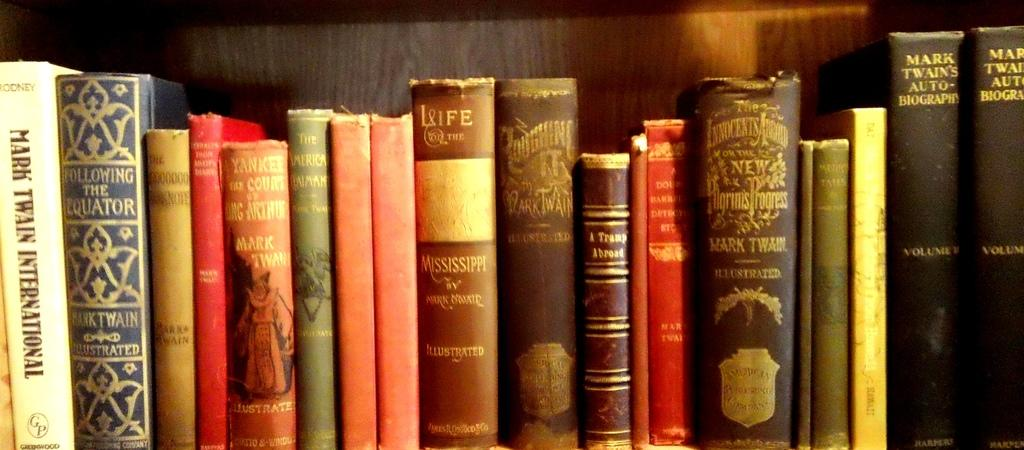<image>
Summarize the visual content of the image. A row of books includes two books titled Mark Twain's Autobiography. 